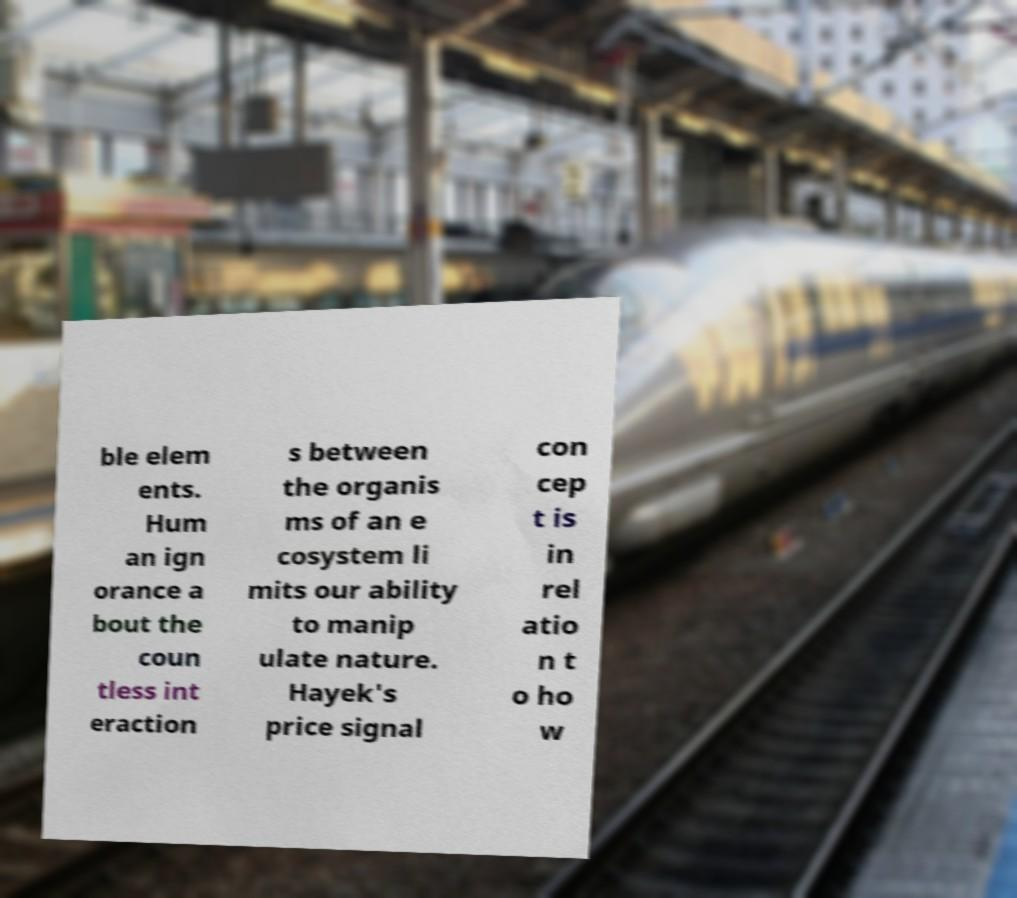Please identify and transcribe the text found in this image. ble elem ents. Hum an ign orance a bout the coun tless int eraction s between the organis ms of an e cosystem li mits our ability to manip ulate nature. Hayek's price signal con cep t is in rel atio n t o ho w 